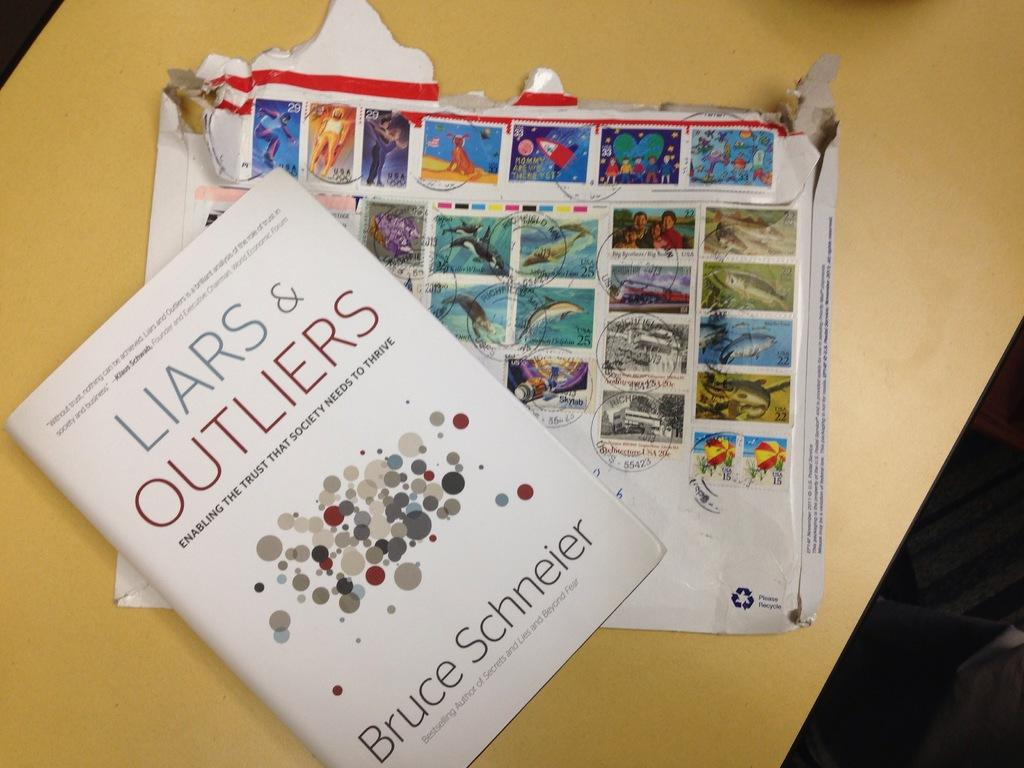What object is placed on the table in the image? There is a book on the table in the image. What else can be seen on the table besides the book? There is a cotton box on the table in the image. What types of images are present on the cotton box? The cotton box has various pictures on it, including persons, umbrellas, fish, kids, men, women, water, flowers, and a dog. What type of locket is hanging around the neck of the person in the image? There is no person or locket present in the image; it only features a book and a cotton box on a table. 